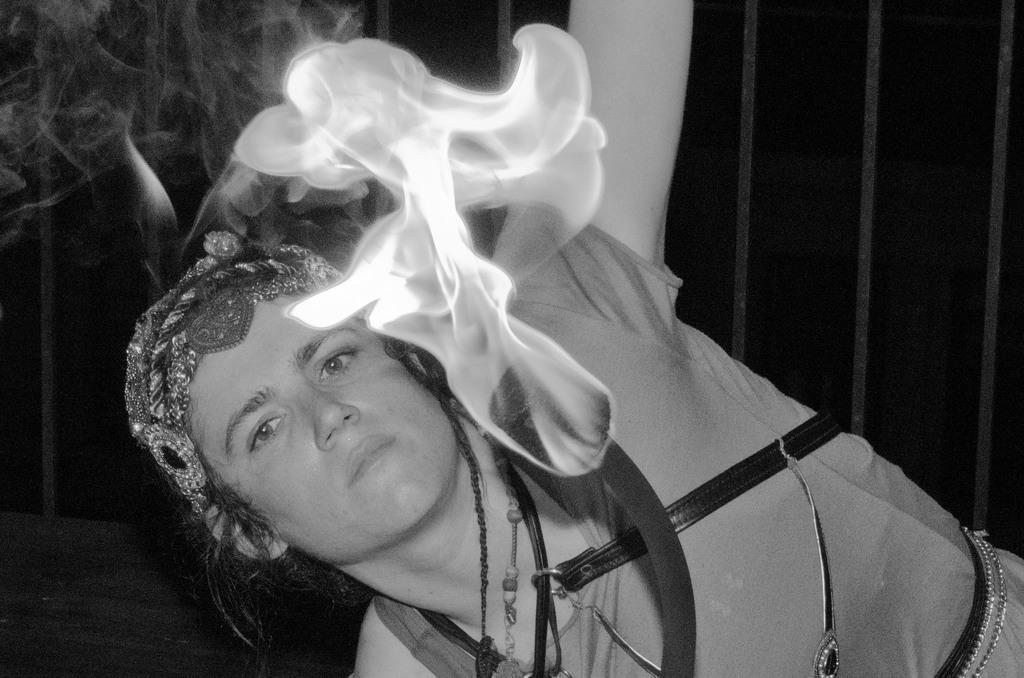Describe this image in one or two sentences. In the image we can see there is a woman and a sponge caught fire. The image is in black and white colour. 